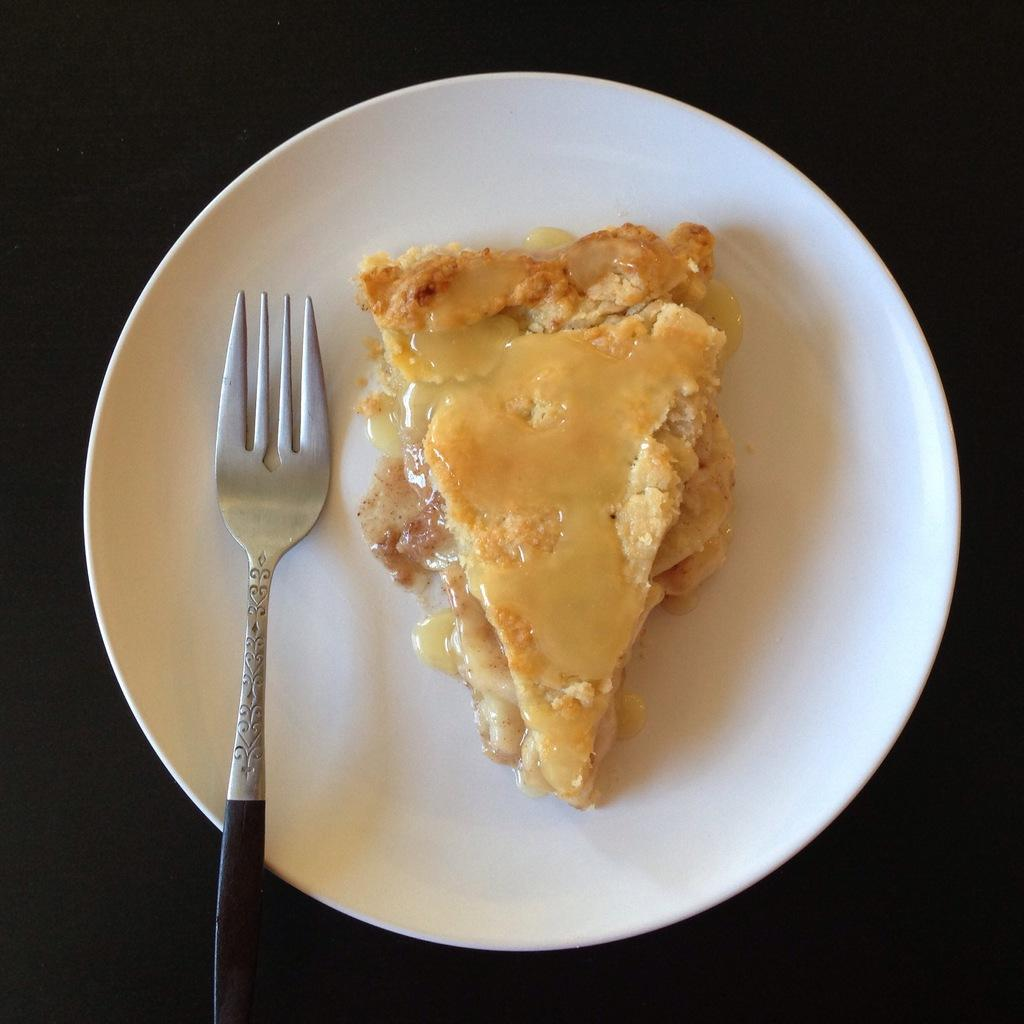What is the main subject of the image? There is a food item in the image. What utensil is present in the image? There is a fork in the image. Where is the fork placed in the image? The fork is placed on a plate. How many deer can be seen interacting with the food item in the image? There are no deer present in the image. What type of toad is sitting on the fork in the image? There are no toads present in the image, and the fork is placed on a plate, not on a toad. 